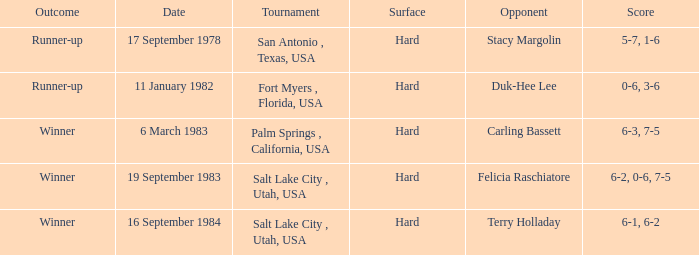What was the outcome of the game against duk-hee lee? 0-6, 3-6. 